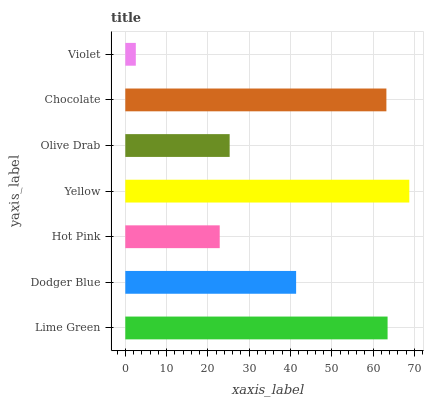Is Violet the minimum?
Answer yes or no. Yes. Is Yellow the maximum?
Answer yes or no. Yes. Is Dodger Blue the minimum?
Answer yes or no. No. Is Dodger Blue the maximum?
Answer yes or no. No. Is Lime Green greater than Dodger Blue?
Answer yes or no. Yes. Is Dodger Blue less than Lime Green?
Answer yes or no. Yes. Is Dodger Blue greater than Lime Green?
Answer yes or no. No. Is Lime Green less than Dodger Blue?
Answer yes or no. No. Is Dodger Blue the high median?
Answer yes or no. Yes. Is Dodger Blue the low median?
Answer yes or no. Yes. Is Violet the high median?
Answer yes or no. No. Is Violet the low median?
Answer yes or no. No. 